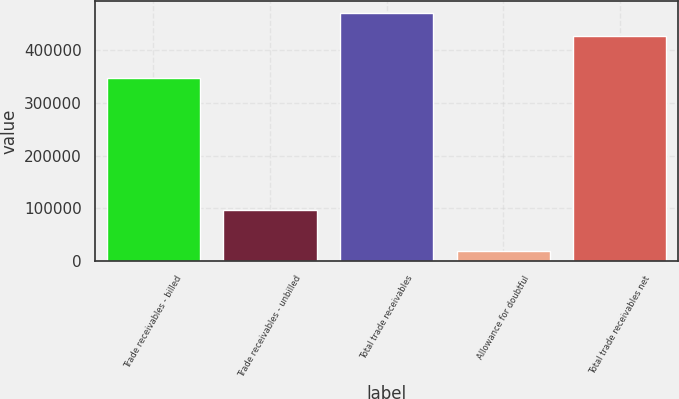Convert chart to OTSL. <chart><loc_0><loc_0><loc_500><loc_500><bar_chart><fcel>Trade receivables - billed<fcel>Trade receivables - unbilled<fcel>Total trade receivables<fcel>Allowance for doubtful<fcel>Total trade receivables net<nl><fcel>348031<fcel>97392<fcel>470228<fcel>17943<fcel>427480<nl></chart> 